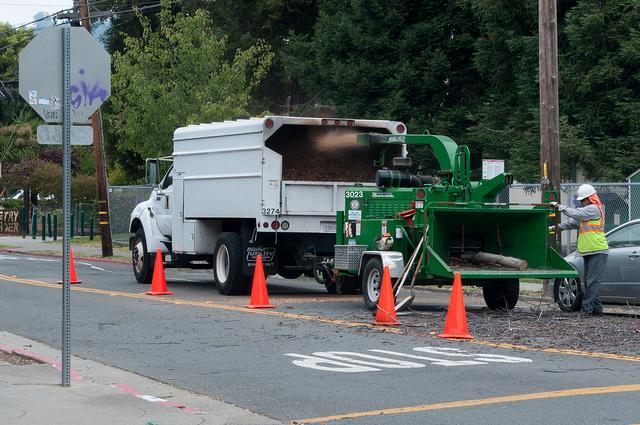How were the purple characters written? spray paint 